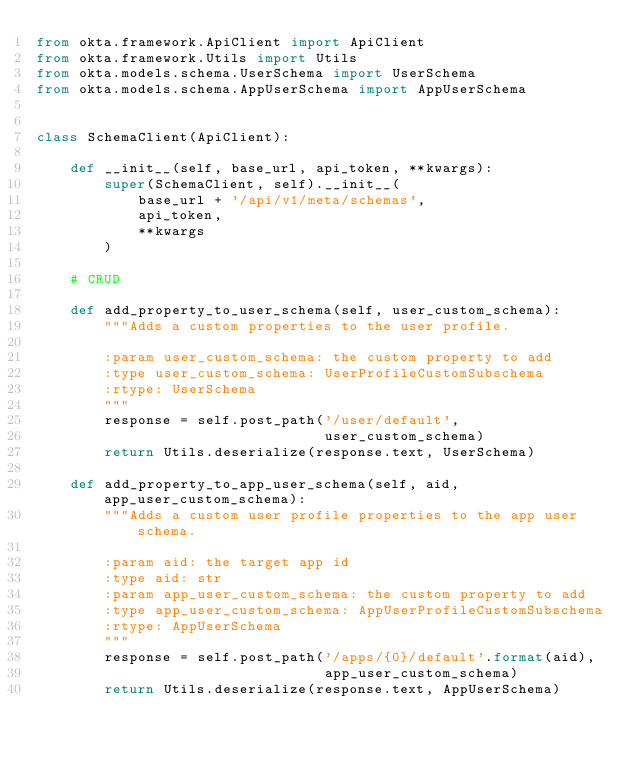<code> <loc_0><loc_0><loc_500><loc_500><_Python_>from okta.framework.ApiClient import ApiClient
from okta.framework.Utils import Utils
from okta.models.schema.UserSchema import UserSchema
from okta.models.schema.AppUserSchema import AppUserSchema


class SchemaClient(ApiClient):

    def __init__(self, base_url, api_token, **kwargs):
        super(SchemaClient, self).__init__(
            base_url + '/api/v1/meta/schemas',
            api_token,
            **kwargs
        )

    # CRUD

    def add_property_to_user_schema(self, user_custom_schema):
        """Adds a custom properties to the user profile.

        :param user_custom_schema: the custom property to add
        :type user_custom_schema: UserProfileCustomSubschema
        :rtype: UserSchema
        """
        response = self.post_path('/user/default',
                                  user_custom_schema)
        return Utils.deserialize(response.text, UserSchema)

    def add_property_to_app_user_schema(self, aid, app_user_custom_schema):
        """Adds a custom user profile properties to the app user schema.

        :param aid: the target app id
        :type aid: str
        :param app_user_custom_schema: the custom property to add
        :type app_user_custom_schema: AppUserProfileCustomSubschema
        :rtype: AppUserSchema
        """
        response = self.post_path('/apps/{0}/default'.format(aid),
                                  app_user_custom_schema)
        return Utils.deserialize(response.text, AppUserSchema)
</code> 